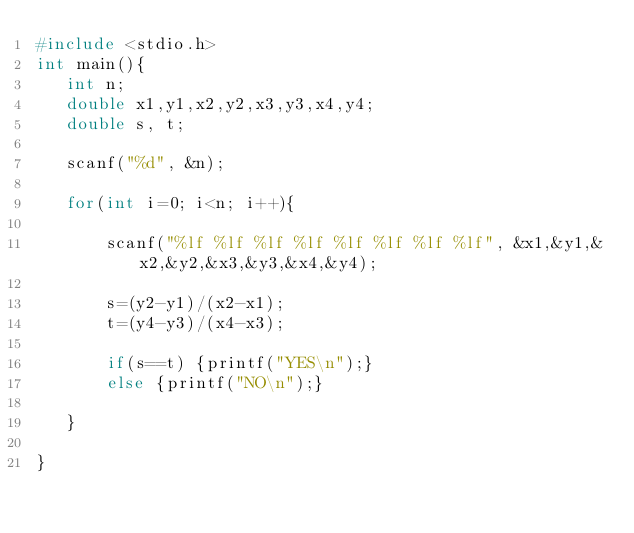Convert code to text. <code><loc_0><loc_0><loc_500><loc_500><_C_>#include <stdio.h>
int main(){
   int n;
   double x1,y1,x2,y2,x3,y3,x4,y4;   
   double s, t;

   scanf("%d", &n);
   
   for(int i=0; i<n; i++){

       scanf("%lf %lf %lf %lf %lf %lf %lf %lf", &x1,&y1,&x2,&y2,&x3,&y3,&x4,&y4);
       
       s=(y2-y1)/(x2-x1);
       t=(y4-y3)/(x4-x3);
       
       if(s==t) {printf("YES\n");}
       else {printf("NO\n");}
       
   } 

}

</code> 